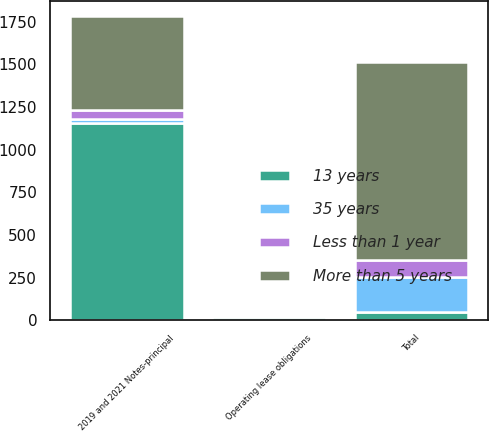Convert chart. <chart><loc_0><loc_0><loc_500><loc_500><stacked_bar_chart><ecel><fcel>Operating lease obligations<fcel>2019 and 2021 Notes-principal<fcel>Total<nl><fcel>13 years<fcel>19<fcel>1157.1<fcel>51.3<nl><fcel>35 years<fcel>5.9<fcel>25.6<fcel>203.1<nl><fcel>Less than 1 year<fcel>6.1<fcel>51.3<fcel>101.4<nl><fcel>More than 5 years<fcel>3.5<fcel>550.8<fcel>1157.6<nl></chart> 